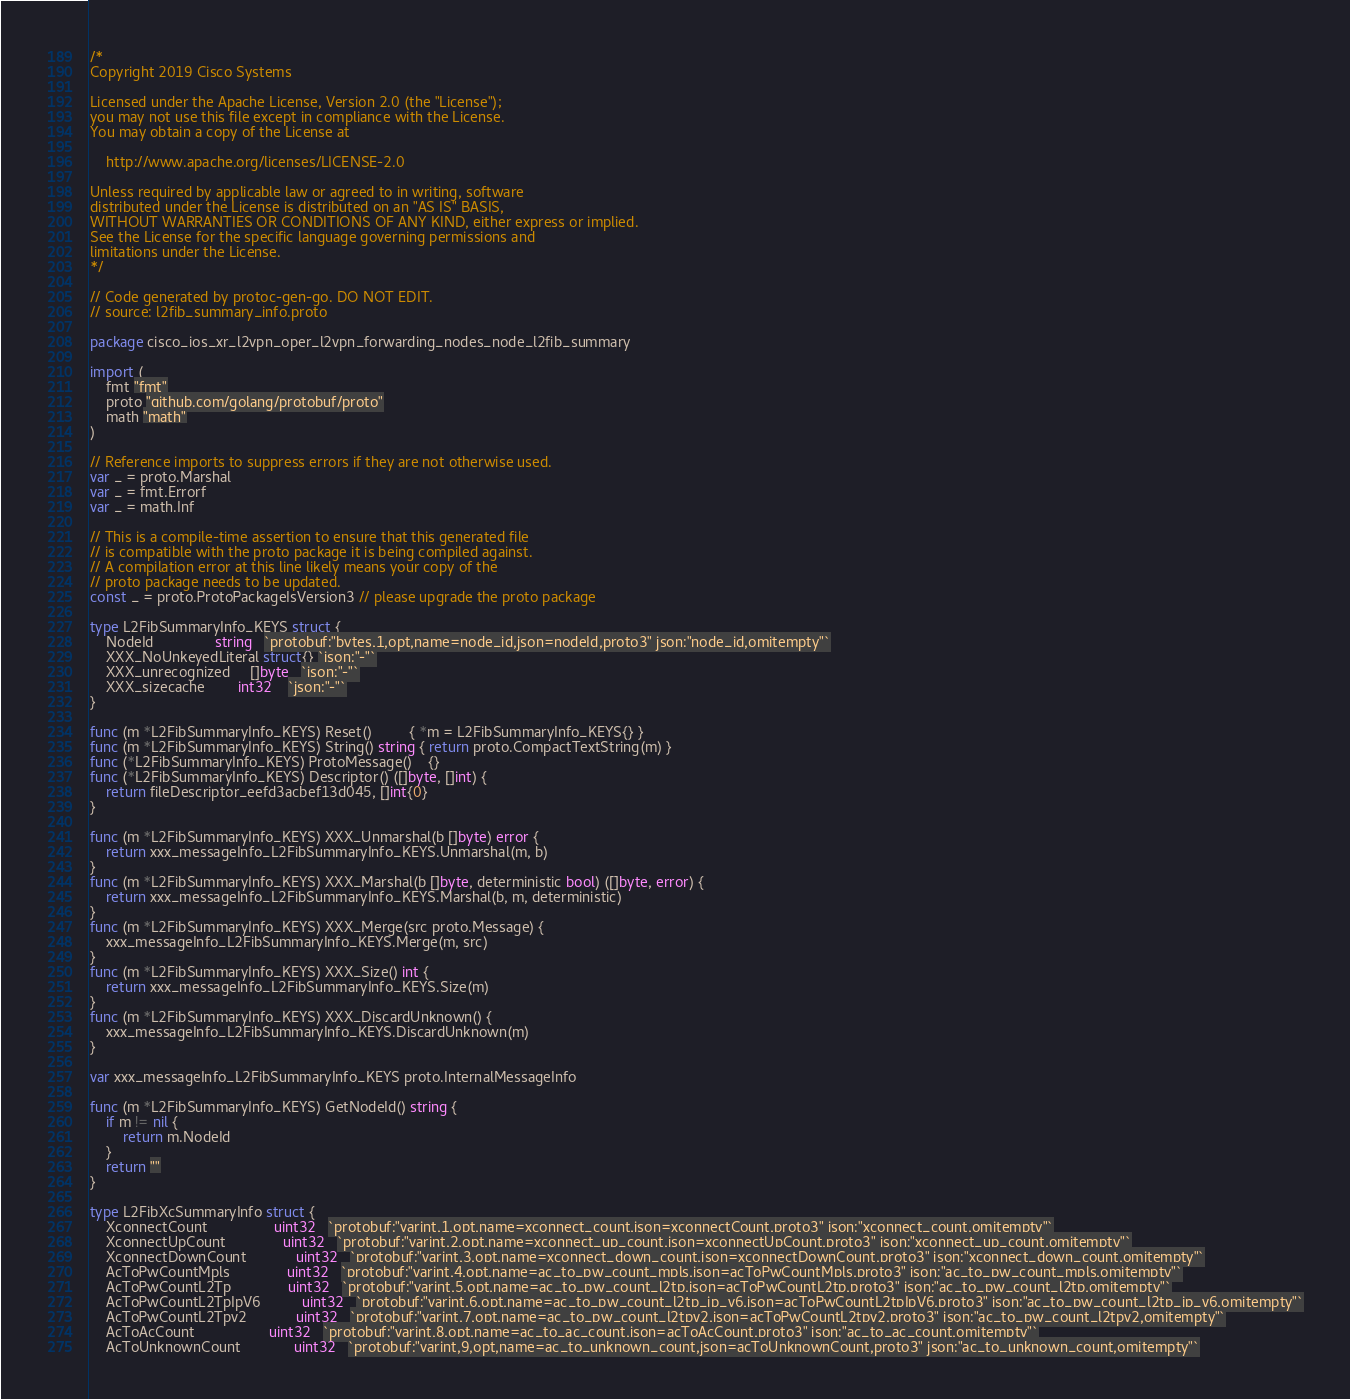<code> <loc_0><loc_0><loc_500><loc_500><_Go_>/*
Copyright 2019 Cisco Systems

Licensed under the Apache License, Version 2.0 (the "License");
you may not use this file except in compliance with the License.
You may obtain a copy of the License at

    http://www.apache.org/licenses/LICENSE-2.0

Unless required by applicable law or agreed to in writing, software
distributed under the License is distributed on an "AS IS" BASIS,
WITHOUT WARRANTIES OR CONDITIONS OF ANY KIND, either express or implied.
See the License for the specific language governing permissions and
limitations under the License.
*/

// Code generated by protoc-gen-go. DO NOT EDIT.
// source: l2fib_summary_info.proto

package cisco_ios_xr_l2vpn_oper_l2vpn_forwarding_nodes_node_l2fib_summary

import (
	fmt "fmt"
	proto "github.com/golang/protobuf/proto"
	math "math"
)

// Reference imports to suppress errors if they are not otherwise used.
var _ = proto.Marshal
var _ = fmt.Errorf
var _ = math.Inf

// This is a compile-time assertion to ensure that this generated file
// is compatible with the proto package it is being compiled against.
// A compilation error at this line likely means your copy of the
// proto package needs to be updated.
const _ = proto.ProtoPackageIsVersion3 // please upgrade the proto package

type L2FibSummaryInfo_KEYS struct {
	NodeId               string   `protobuf:"bytes,1,opt,name=node_id,json=nodeId,proto3" json:"node_id,omitempty"`
	XXX_NoUnkeyedLiteral struct{} `json:"-"`
	XXX_unrecognized     []byte   `json:"-"`
	XXX_sizecache        int32    `json:"-"`
}

func (m *L2FibSummaryInfo_KEYS) Reset()         { *m = L2FibSummaryInfo_KEYS{} }
func (m *L2FibSummaryInfo_KEYS) String() string { return proto.CompactTextString(m) }
func (*L2FibSummaryInfo_KEYS) ProtoMessage()    {}
func (*L2FibSummaryInfo_KEYS) Descriptor() ([]byte, []int) {
	return fileDescriptor_eefd3acbef13d045, []int{0}
}

func (m *L2FibSummaryInfo_KEYS) XXX_Unmarshal(b []byte) error {
	return xxx_messageInfo_L2FibSummaryInfo_KEYS.Unmarshal(m, b)
}
func (m *L2FibSummaryInfo_KEYS) XXX_Marshal(b []byte, deterministic bool) ([]byte, error) {
	return xxx_messageInfo_L2FibSummaryInfo_KEYS.Marshal(b, m, deterministic)
}
func (m *L2FibSummaryInfo_KEYS) XXX_Merge(src proto.Message) {
	xxx_messageInfo_L2FibSummaryInfo_KEYS.Merge(m, src)
}
func (m *L2FibSummaryInfo_KEYS) XXX_Size() int {
	return xxx_messageInfo_L2FibSummaryInfo_KEYS.Size(m)
}
func (m *L2FibSummaryInfo_KEYS) XXX_DiscardUnknown() {
	xxx_messageInfo_L2FibSummaryInfo_KEYS.DiscardUnknown(m)
}

var xxx_messageInfo_L2FibSummaryInfo_KEYS proto.InternalMessageInfo

func (m *L2FibSummaryInfo_KEYS) GetNodeId() string {
	if m != nil {
		return m.NodeId
	}
	return ""
}

type L2FibXcSummaryInfo struct {
	XconnectCount                uint32   `protobuf:"varint,1,opt,name=xconnect_count,json=xconnectCount,proto3" json:"xconnect_count,omitempty"`
	XconnectUpCount              uint32   `protobuf:"varint,2,opt,name=xconnect_up_count,json=xconnectUpCount,proto3" json:"xconnect_up_count,omitempty"`
	XconnectDownCount            uint32   `protobuf:"varint,3,opt,name=xconnect_down_count,json=xconnectDownCount,proto3" json:"xconnect_down_count,omitempty"`
	AcToPwCountMpls              uint32   `protobuf:"varint,4,opt,name=ac_to_pw_count_mpls,json=acToPwCountMpls,proto3" json:"ac_to_pw_count_mpls,omitempty"`
	AcToPwCountL2Tp              uint32   `protobuf:"varint,5,opt,name=ac_to_pw_count_l2tp,json=acToPwCountL2tp,proto3" json:"ac_to_pw_count_l2tp,omitempty"`
	AcToPwCountL2TpIpV6          uint32   `protobuf:"varint,6,opt,name=ac_to_pw_count_l2tp_ip_v6,json=acToPwCountL2tpIpV6,proto3" json:"ac_to_pw_count_l2tp_ip_v6,omitempty"`
	AcToPwCountL2Tpv2            uint32   `protobuf:"varint,7,opt,name=ac_to_pw_count_l2tpv2,json=acToPwCountL2tpv2,proto3" json:"ac_to_pw_count_l2tpv2,omitempty"`
	AcToAcCount                  uint32   `protobuf:"varint,8,opt,name=ac_to_ac_count,json=acToAcCount,proto3" json:"ac_to_ac_count,omitempty"`
	AcToUnknownCount             uint32   `protobuf:"varint,9,opt,name=ac_to_unknown_count,json=acToUnknownCount,proto3" json:"ac_to_unknown_count,omitempty"`</code> 